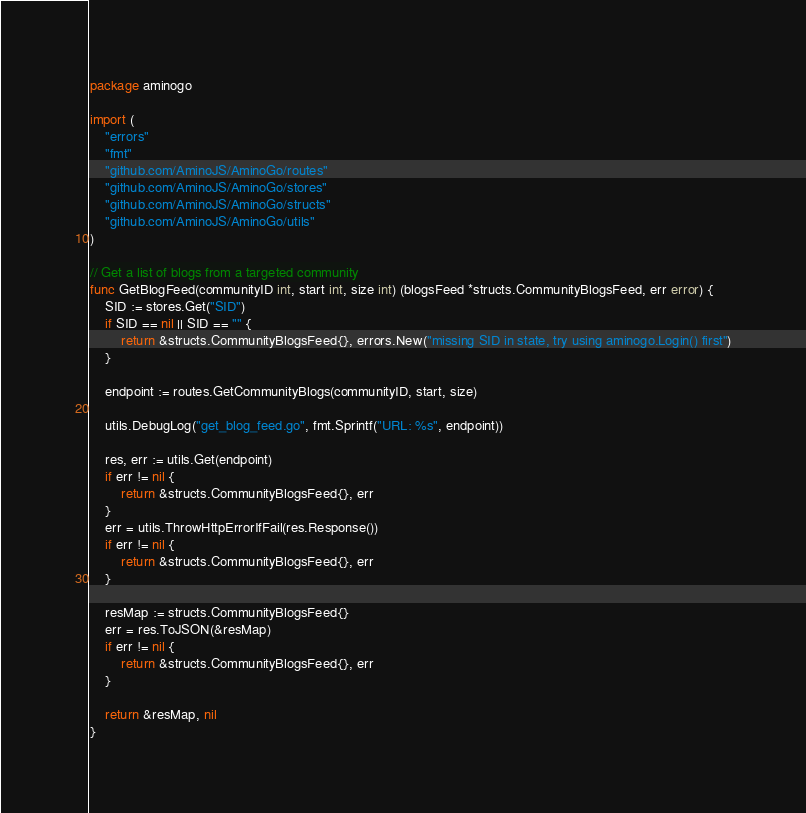<code> <loc_0><loc_0><loc_500><loc_500><_Go_>package aminogo

import (
	"errors"
	"fmt"
	"github.com/AminoJS/AminoGo/routes"
	"github.com/AminoJS/AminoGo/stores"
	"github.com/AminoJS/AminoGo/structs"
	"github.com/AminoJS/AminoGo/utils"
)

// Get a list of blogs from a targeted community
func GetBlogFeed(communityID int, start int, size int) (blogsFeed *structs.CommunityBlogsFeed, err error) {
	SID := stores.Get("SID")
	if SID == nil || SID == "" {
		return &structs.CommunityBlogsFeed{}, errors.New("missing SID in state, try using aminogo.Login() first")
	}

	endpoint := routes.GetCommunityBlogs(communityID, start, size)

	utils.DebugLog("get_blog_feed.go", fmt.Sprintf("URL: %s", endpoint))

	res, err := utils.Get(endpoint)
	if err != nil {
		return &structs.CommunityBlogsFeed{}, err
	}
	err = utils.ThrowHttpErrorIfFail(res.Response())
	if err != nil {
		return &structs.CommunityBlogsFeed{}, err
	}

	resMap := structs.CommunityBlogsFeed{}
	err = res.ToJSON(&resMap)
	if err != nil {
		return &structs.CommunityBlogsFeed{}, err
	}

	return &resMap, nil
}
</code> 